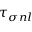<formula> <loc_0><loc_0><loc_500><loc_500>\tau _ { \sigma n l }</formula> 